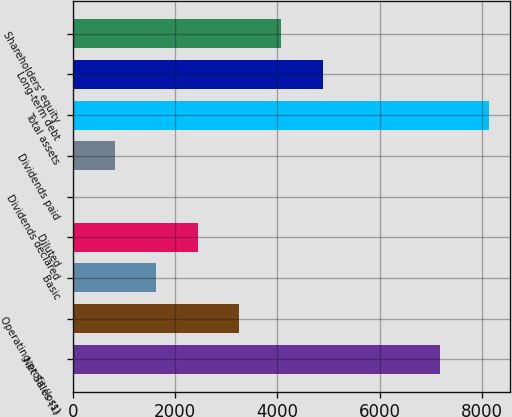Convert chart to OTSL. <chart><loc_0><loc_0><loc_500><loc_500><bar_chart><fcel>Net Sales (1)<fcel>Operating profit (loss)<fcel>Basic<fcel>Diluted<fcel>Dividends declared<fcel>Dividends paid<fcel>Total assets<fcel>Long-term debt<fcel>Shareholders' equity<nl><fcel>7183<fcel>3255.78<fcel>1628.04<fcel>2441.91<fcel>0.3<fcel>814.17<fcel>8139<fcel>4883.52<fcel>4069.65<nl></chart> 